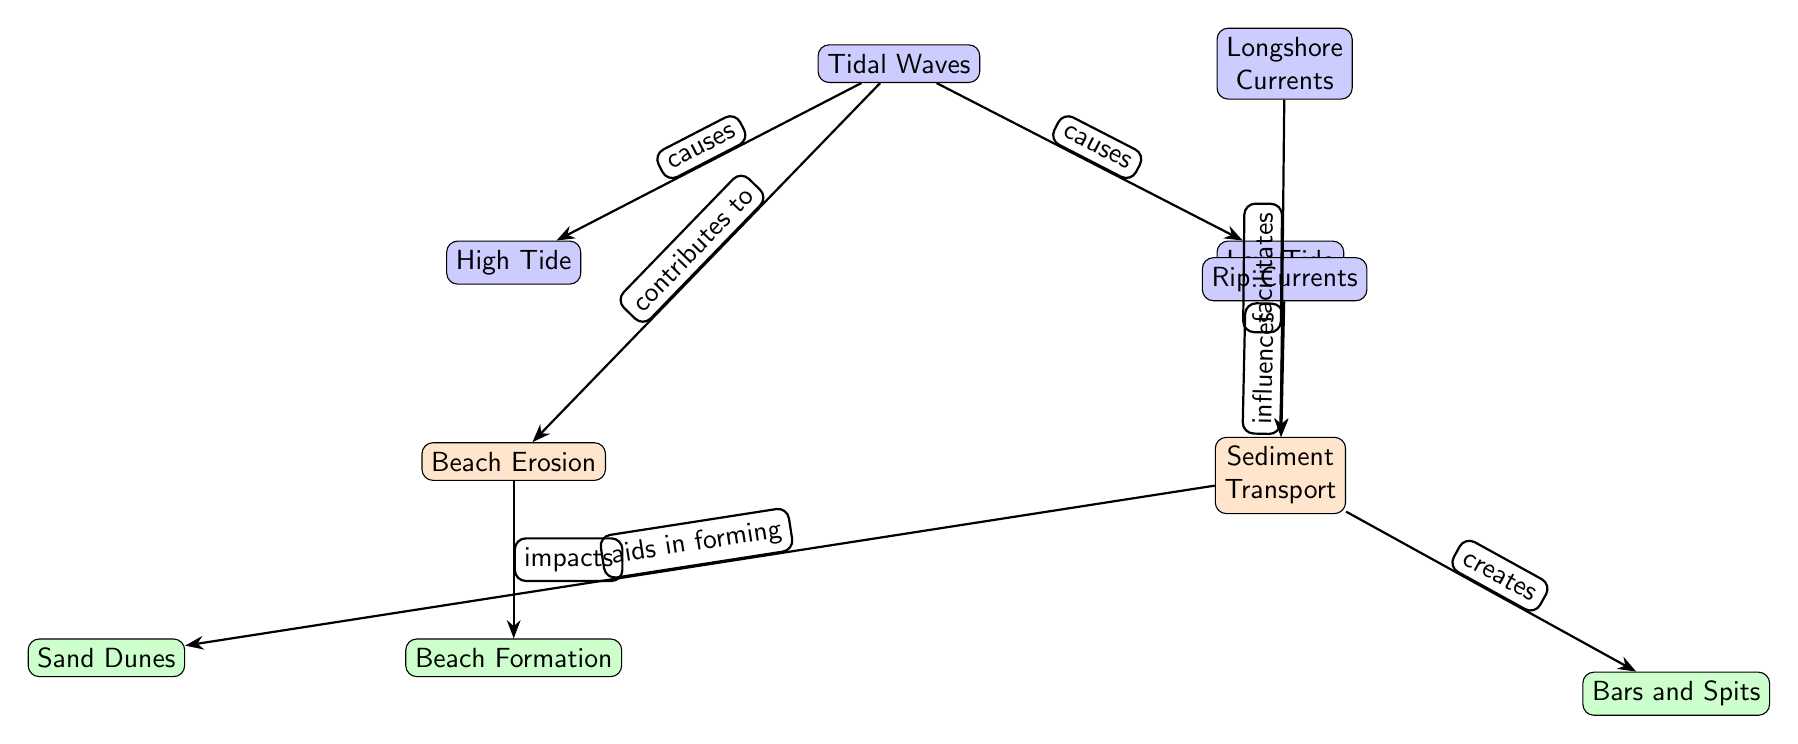What causes high tide? The diagram indicates that high tide is caused by tidal waves, as shown by the directed edge labeled "causes" from the tidal wave node to the high tide node.
Answer: Tidal Waves What influences sediment transport? The diagram shows that sediment transport is influenced by rip currents, which is depicted by the directed edge labeled "influences" from the rip currents node to the sediment transport node.
Answer: Rip Currents How many processes are shown in the diagram? There are four processes depicted: beach erosion, sediment transport, beach formation, and the creation of bars and spits, which can be counted by identifying the process nodes.
Answer: Four What do longshore currents facilitate? The diagram explicitly states that longshore currents facilitate sediment transport, indicated by the edge labeled "facilitates" between the longshore currents node and the sediment transport node.
Answer: Sediment Transport What impacts beach formation? According to the diagram, beach formation is impacted by beach erosion, indicated by the edge labeled "impacts" from the beach erosion node to the beach formation node.
Answer: Beach Erosion What is created by sediment transport? The diagram indicates that sediment transport creates bars and spits, as shown by the edge labeled "creates" between the sediment transport node and the bars and spits node.
Answer: Bars and Spits Which two factors are related to tidal waves? The diagram shows that tidal waves cause both high tide and low tide, represented by the edges labeled "causes" leading to those nodes, meaning both are influenced by tidal waves.
Answer: High Tide, Low Tide What aids in forming sand dunes? The diagram illustrates that sediment transport aids in forming sand dunes, indicated by the directed edge labeled "aids in forming" connecting the sediment transport node to the sand dunes node.
Answer: Sediment Transport What is the relationship between beach erosion and beach formation? The diagram shows that beach erosion impacts beach formation, depicted by the directed edge labeled "impacts" from the beach erosion node to the beach formation node.
Answer: Impacts 